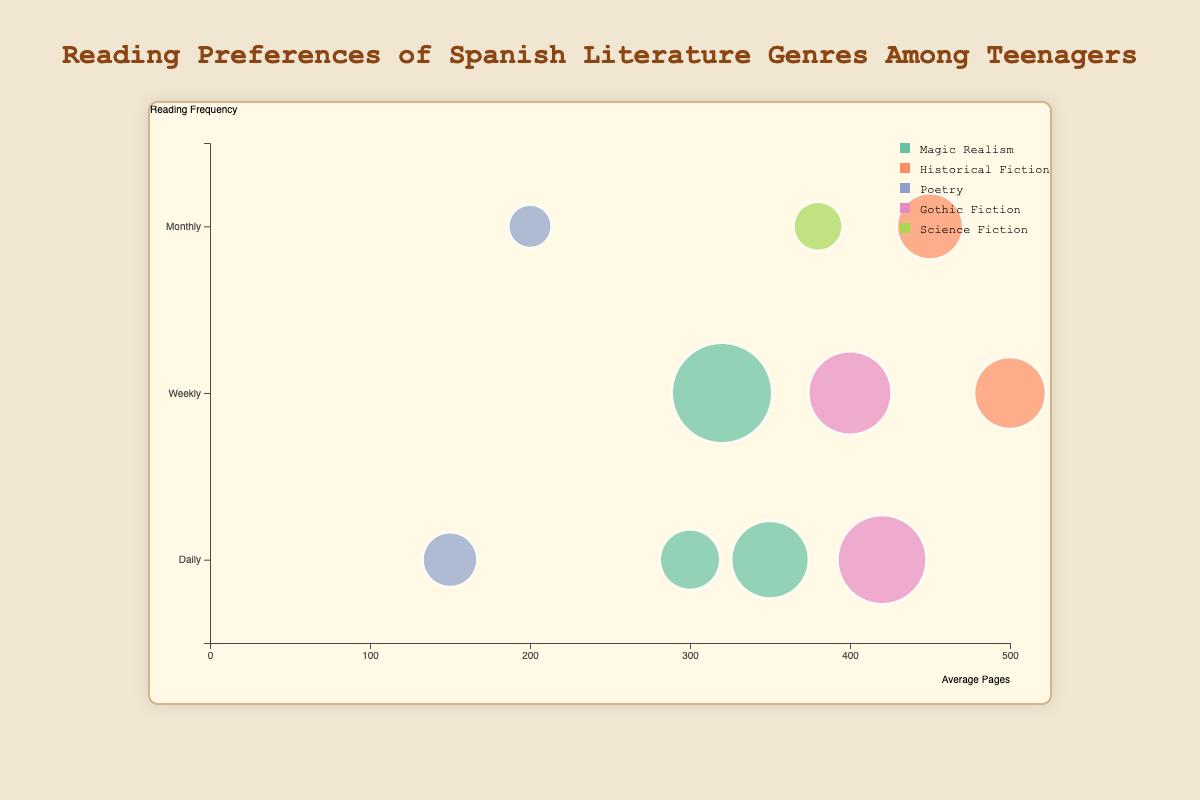What genre has the highest number of readers? The largest bubble size indicates the highest number of readers. In the chart, the largest bubble belongs to "Gothic Fiction" by Dolores Redondo with 60 readers.
Answer: Gothic Fiction What's the average number of pages for books read daily? Find the data points with "Daily" reading frequency. These are:
- Magic Realism (Gabriel García Márquez) - 350 pages
- Poetry (Federico García Lorca) - 150 pages
- Magic Realism (Laura Esquivel) - 300 pages
- Gothic Fiction (Dolores Redondo) - 420 pages
The average is (350 + 150 + 300 + 420) / 4 = 1220 / 4 = 305
Answer: 305 Which author has the least number of readers when comparing the monthly reading frequency? Identify books with "Monthly" frequency, then find the one with the fewest readers. These are:
- Historical Fiction (Arturo Pérez-Reverte) - 40 readers
- Science Fiction (Javier Sierra) - 25 readers
- Poetry (Octavio Paz) - 20 readers
The smallest number of readers is 20, which belongs to Octavio Paz.
Answer: Octavio Paz Compare the average pages of books read weekly in two genres: Magic Realism and Historical Fiction. For Magic Realism, weekly data has:
- Isabel Allende - 320 pages
For Historical Fiction, weekly data has:
- Almudena Grandes - 500 pages
320 pages < 500 pages; Historical Fiction has more average pages read weekly.
Answer: Historical Fiction What's the reading frequency with the highest average pages per book? Calculate average pages for each reading frequency:
- Daily: (350 + 150 + 300 + 420) / 4 = 305 pages
- Weekly: (320 + 500 + 400) / 3 = 406.67 pages
- Monthly: (450 + 380 + 200) / 3 = 343.33 pages
The highest average is 406.67 pages for weekly reading.
Answer: Weekly Which author has the highest average pages per book among those read monthly? Only consider authors with "Monthly" frequency:
- Arturo Pérez-Reverte - 450 pages
- Javier Sierra - 380 pages
- Octavio Paz - 200 pages
Arturo Pérez-Reverte has the highest with 450 pages.
Answer: Arturo Pérez-Reverte How many different genres are represented in the chart? Count the unique genres in the dataset. They are "Magic Realism," "Historical Fiction," "Poetry," "Gothic Fiction," and "Science Fiction." This gives us 5 genres.
Answer: 5 Which genre has the most readers overall? Sum the readers for each genre:
- Magic Realism: 50 + 70 + 35 = 155
- Historical Fiction: 40 + 45 = 85
- Poetry: 30 + 20 = 50
- Gothic Fiction: 55 + 60 = 115
- Science Fiction: 25
The genre with the most readers is Magic Realism with 155 readers.
Answer: Magic Realism 